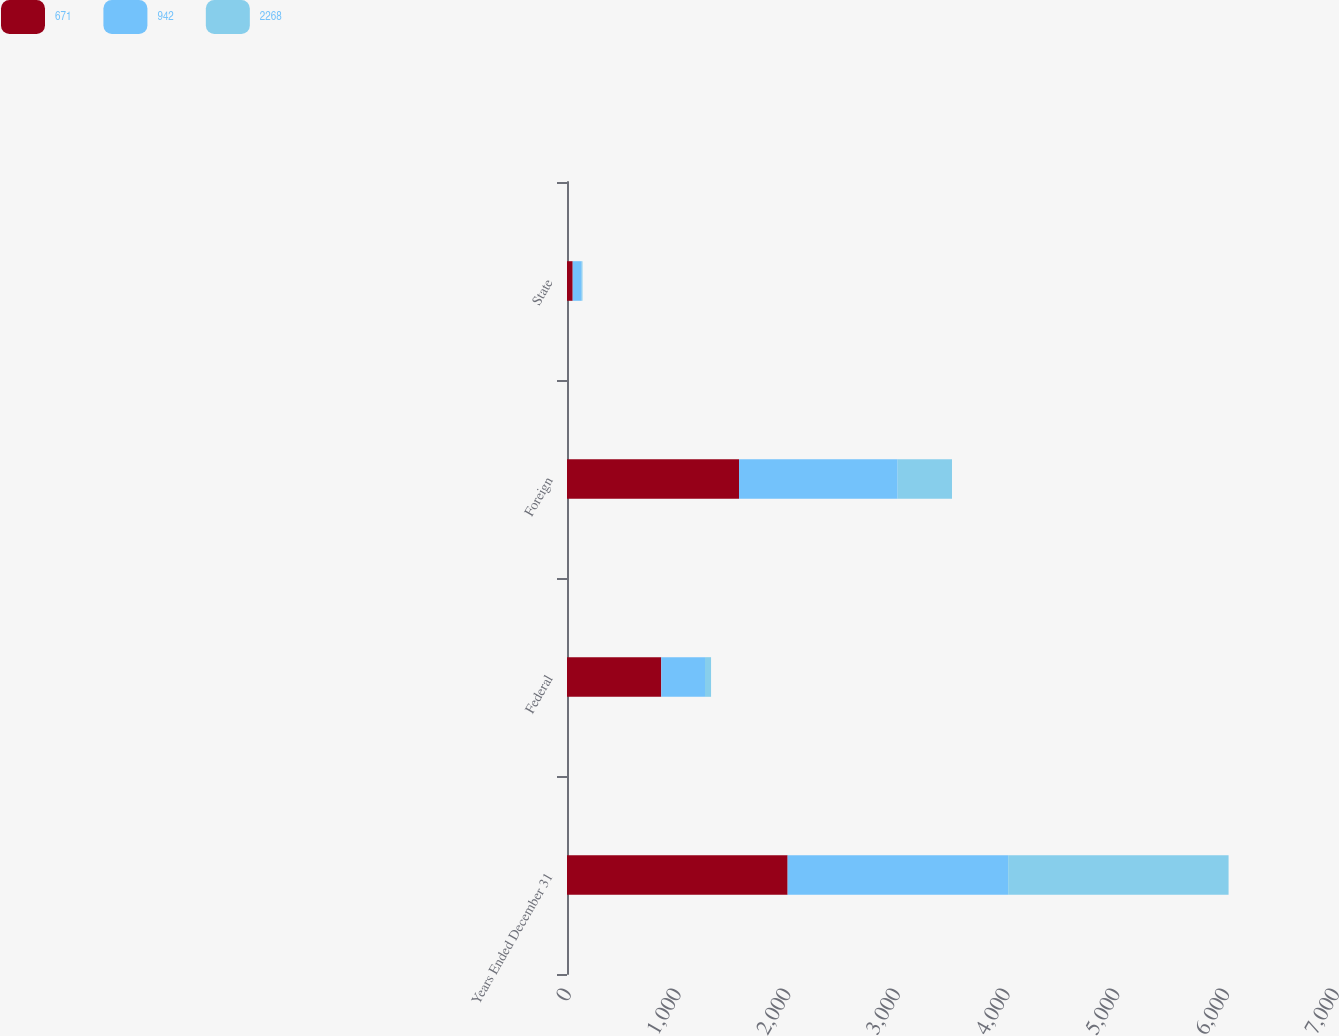Convert chart. <chart><loc_0><loc_0><loc_500><loc_500><stacked_bar_chart><ecel><fcel>Years Ended December 31<fcel>Federal<fcel>Foreign<fcel>State<nl><fcel>671<fcel>2011<fcel>859<fcel>1568<fcel>52<nl><fcel>942<fcel>2010<fcel>399<fcel>1446<fcel>82<nl><fcel>2268<fcel>2009<fcel>55<fcel>495<fcel>7<nl></chart> 